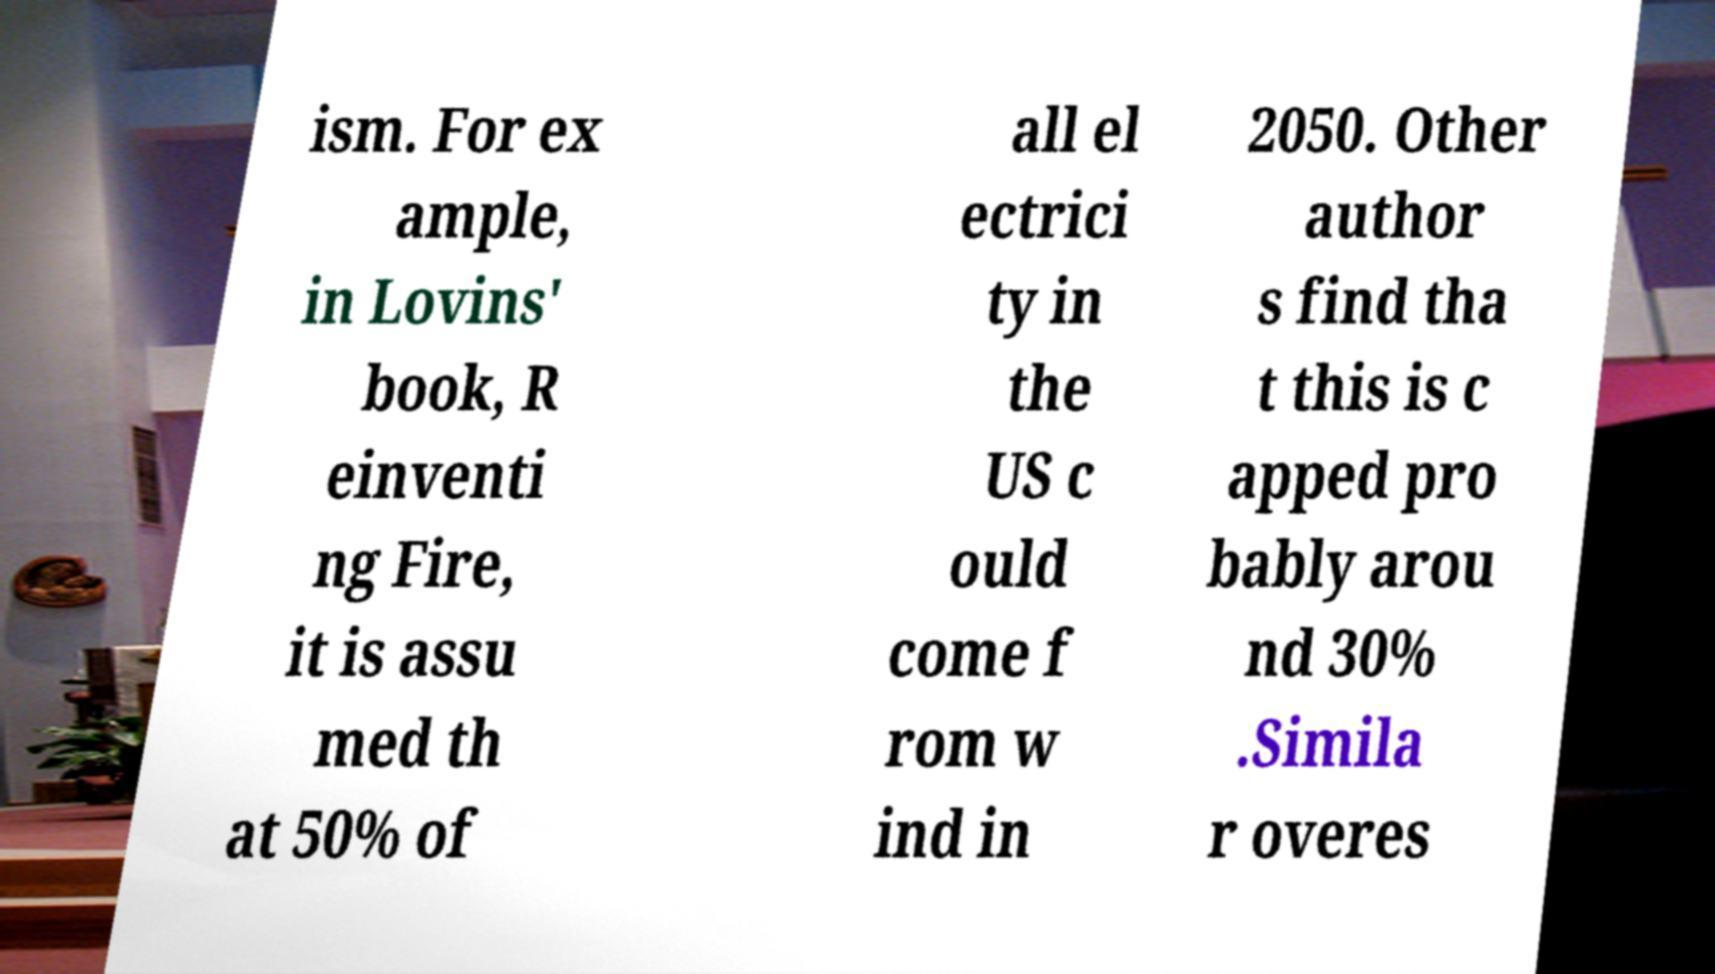Please identify and transcribe the text found in this image. ism. For ex ample, in Lovins' book, R einventi ng Fire, it is assu med th at 50% of all el ectrici ty in the US c ould come f rom w ind in 2050. Other author s find tha t this is c apped pro bably arou nd 30% .Simila r overes 